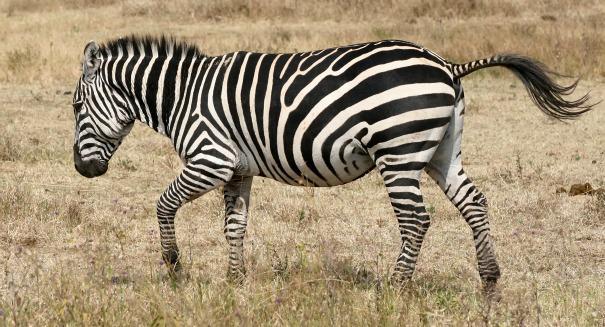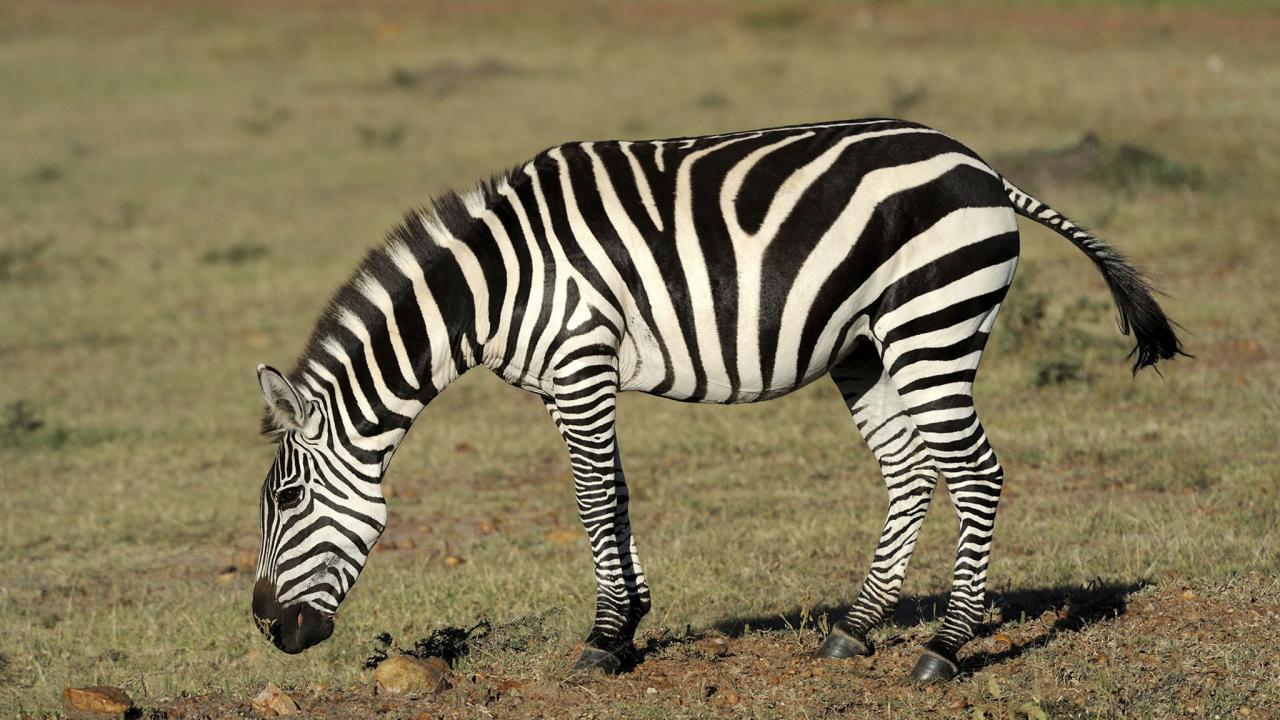The first image is the image on the left, the second image is the image on the right. Given the left and right images, does the statement "Each image contains one zebra standing with head and body in profile, but the zebra on the right has its head bent lower." hold true? Answer yes or no. Yes. The first image is the image on the left, the second image is the image on the right. Analyze the images presented: Is the assertion "One zebra is facing right." valid? Answer yes or no. No. 